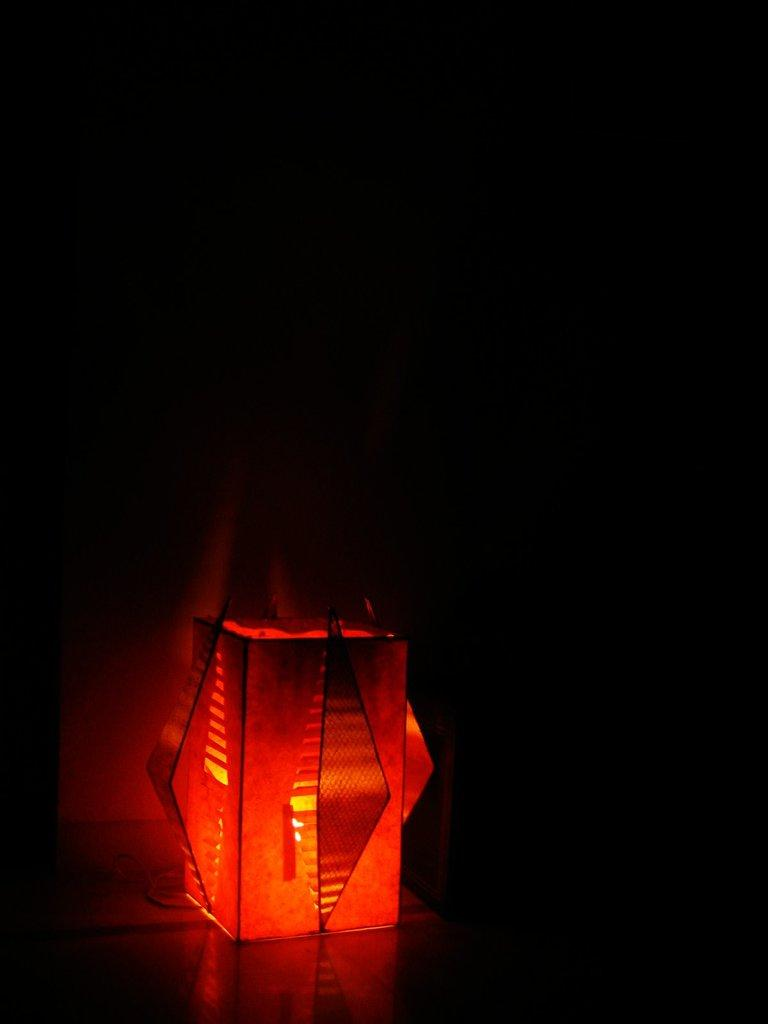What type of object is present at the bottom of the image? There is a light in the image, and it is located at the bottom. What color is the light in the image? The light is red in color. Can you see any snails crawling on the red light in the image? There are no snails present in the image, and therefore none can be seen crawling on the red light. 